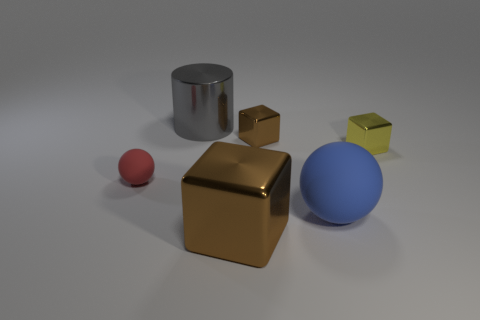Subtract all blue spheres. How many brown cubes are left? 2 Subtract 1 cubes. How many cubes are left? 2 Subtract all yellow metal cubes. How many cubes are left? 2 Add 4 big yellow shiny things. How many objects exist? 10 Subtract all purple cubes. Subtract all blue spheres. How many cubes are left? 3 Subtract 0 green cubes. How many objects are left? 6 Subtract all spheres. How many objects are left? 4 Subtract all large things. Subtract all small matte cubes. How many objects are left? 3 Add 3 big objects. How many big objects are left? 6 Add 5 tiny matte cubes. How many tiny matte cubes exist? 5 